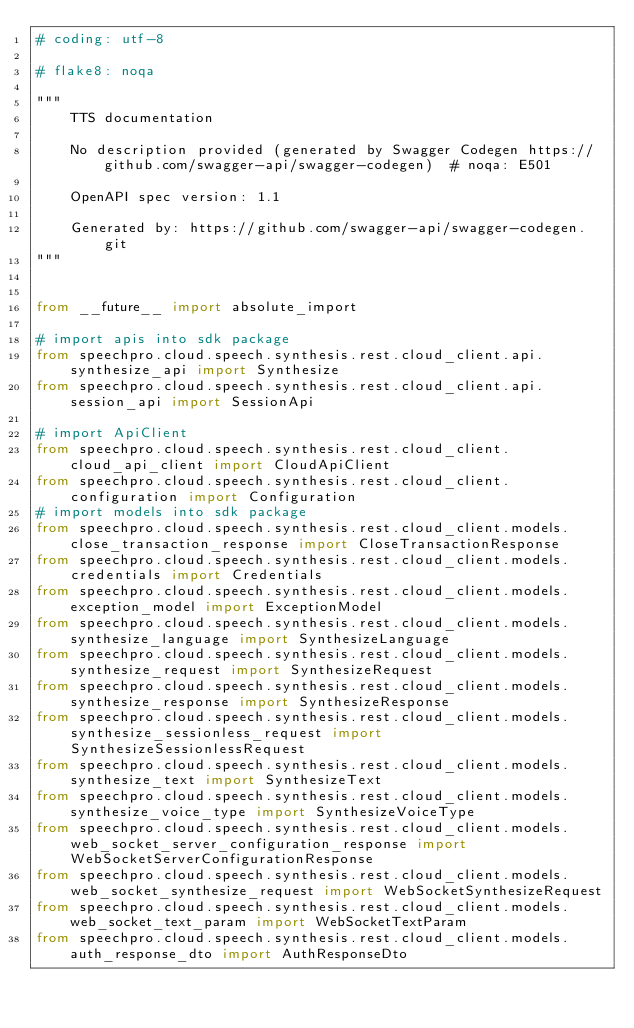<code> <loc_0><loc_0><loc_500><loc_500><_Python_># coding: utf-8

# flake8: noqa

"""
    TTS documentation

    No description provided (generated by Swagger Codegen https://github.com/swagger-api/swagger-codegen)  # noqa: E501

    OpenAPI spec version: 1.1

    Generated by: https://github.com/swagger-api/swagger-codegen.git
"""


from __future__ import absolute_import

# import apis into sdk package
from speechpro.cloud.speech.synthesis.rest.cloud_client.api.synthesize_api import Synthesize
from speechpro.cloud.speech.synthesis.rest.cloud_client.api.session_api import SessionApi

# import ApiClient
from speechpro.cloud.speech.synthesis.rest.cloud_client.cloud_api_client import CloudApiClient
from speechpro.cloud.speech.synthesis.rest.cloud_client.configuration import Configuration
# import models into sdk package
from speechpro.cloud.speech.synthesis.rest.cloud_client.models.close_transaction_response import CloseTransactionResponse
from speechpro.cloud.speech.synthesis.rest.cloud_client.models.credentials import Credentials
from speechpro.cloud.speech.synthesis.rest.cloud_client.models.exception_model import ExceptionModel
from speechpro.cloud.speech.synthesis.rest.cloud_client.models.synthesize_language import SynthesizeLanguage
from speechpro.cloud.speech.synthesis.rest.cloud_client.models.synthesize_request import SynthesizeRequest
from speechpro.cloud.speech.synthesis.rest.cloud_client.models.synthesize_response import SynthesizeResponse
from speechpro.cloud.speech.synthesis.rest.cloud_client.models.synthesize_sessionless_request import SynthesizeSessionlessRequest
from speechpro.cloud.speech.synthesis.rest.cloud_client.models.synthesize_text import SynthesizeText
from speechpro.cloud.speech.synthesis.rest.cloud_client.models.synthesize_voice_type import SynthesizeVoiceType
from speechpro.cloud.speech.synthesis.rest.cloud_client.models.web_socket_server_configuration_response import WebSocketServerConfigurationResponse
from speechpro.cloud.speech.synthesis.rest.cloud_client.models.web_socket_synthesize_request import WebSocketSynthesizeRequest
from speechpro.cloud.speech.synthesis.rest.cloud_client.models.web_socket_text_param import WebSocketTextParam
from speechpro.cloud.speech.synthesis.rest.cloud_client.models.auth_response_dto import AuthResponseDto</code> 